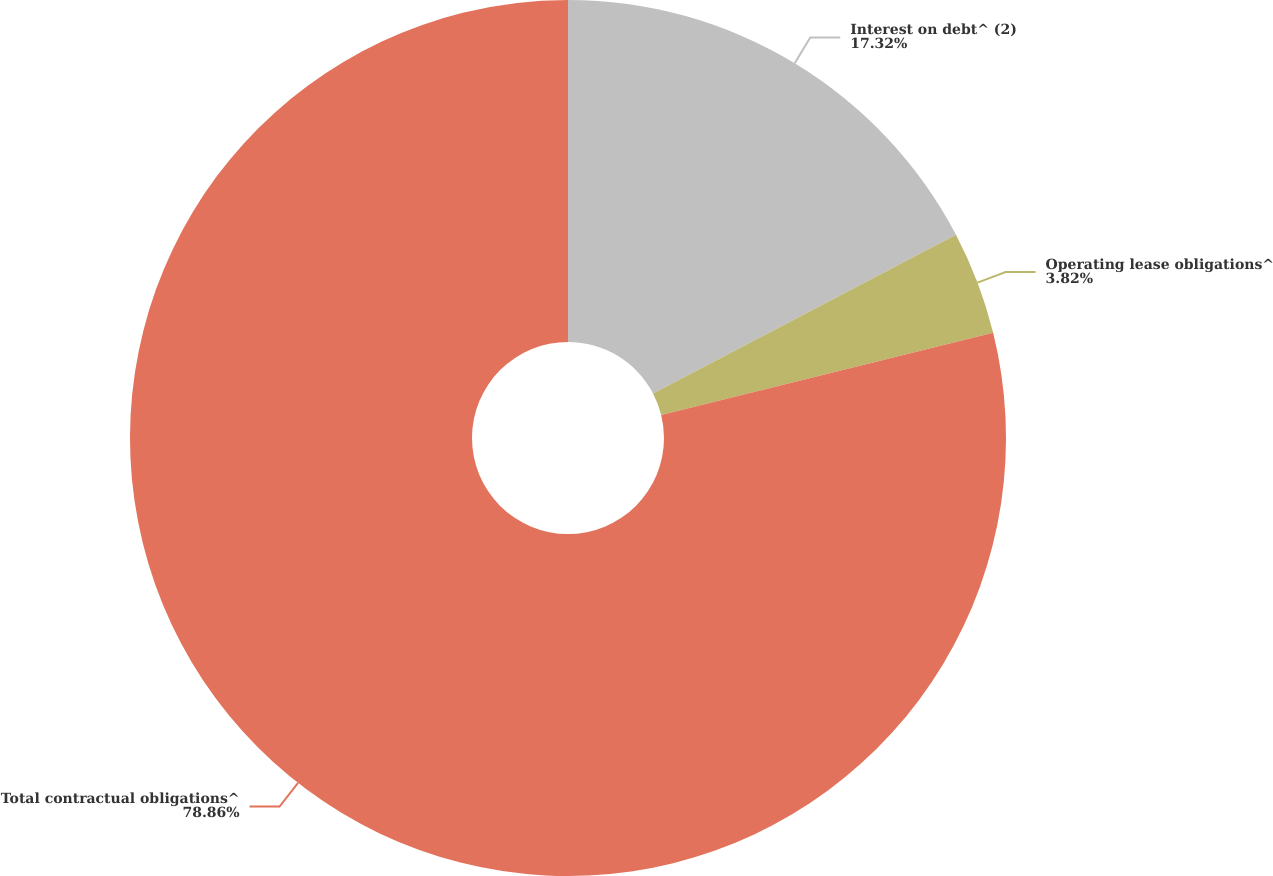Convert chart to OTSL. <chart><loc_0><loc_0><loc_500><loc_500><pie_chart><fcel>Interest on debt^ (2)<fcel>Operating lease obligations^<fcel>Total contractual obligations^<nl><fcel>17.32%<fcel>3.82%<fcel>78.87%<nl></chart> 